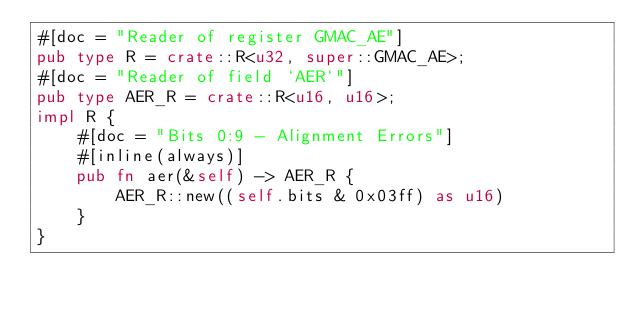<code> <loc_0><loc_0><loc_500><loc_500><_Rust_>#[doc = "Reader of register GMAC_AE"]
pub type R = crate::R<u32, super::GMAC_AE>;
#[doc = "Reader of field `AER`"]
pub type AER_R = crate::R<u16, u16>;
impl R {
    #[doc = "Bits 0:9 - Alignment Errors"]
    #[inline(always)]
    pub fn aer(&self) -> AER_R {
        AER_R::new((self.bits & 0x03ff) as u16)
    }
}
</code> 